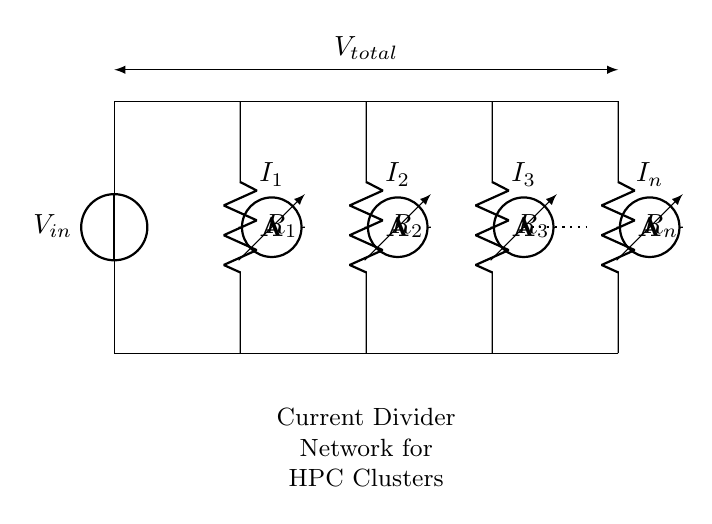What is the total voltage supplied? The total voltage supplied is indicated by \( V_{total} \), which appears above the circuit and connects all resistors in parallel.
Answer: V total How many resistors are in the current divider? The circuit shows a total of four resistors labeled \( R_1, R_2, R_3, \) and \( R_n \), which are all connected in parallel.
Answer: Four What is the main function of the current divider network? The main function of the current divider network is to distribute the input current proportionally across the various resistors, allowing for precise control over current flows in high-performance computing clusters.
Answer: Current distribution What do the ammeters measure in this circuit? The ammeters are positioned within each branch of the circuit, measuring the current flowing through each resistor, labeled \( I_1, I_2, I_3, \) and \( I_n \).
Answer: Branch currents If \( R_1 \) has a resistance of 10 ohms and \( R_2 \) has a resistance of 20 ohms, which resistor will receive less current? Since resistors in a current divider are in parallel, the current divides inversely proportional to their resistances; therefore, \( R_2 \), which is higher in resistance, will receive less current compared to \( R_1 \).
Answer: R2 What dictates the amount of current each resistor receives? The amount of current each resistor receives is dictated by its resistance relative to the total resistance of the network; lower resistance allows more current to pass through that branch.
Answer: Resistance values 